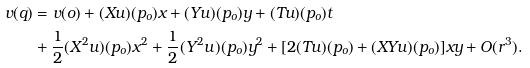<formula> <loc_0><loc_0><loc_500><loc_500>v ( q ) & = v ( o ) + ( X u ) ( p _ { o } ) x + ( Y u ) ( p _ { o } ) y + ( T u ) ( p _ { o } ) t \\ & + \frac { 1 } { 2 } ( X ^ { 2 } u ) ( p _ { o } ) x ^ { 2 } + \frac { 1 } { 2 } ( Y ^ { 2 } u ) ( p _ { o } ) y ^ { 2 } + [ 2 ( T u ) ( p _ { o } ) + ( X Y u ) ( p _ { o } ) ] x y + O ( r ^ { 3 } ) .</formula> 